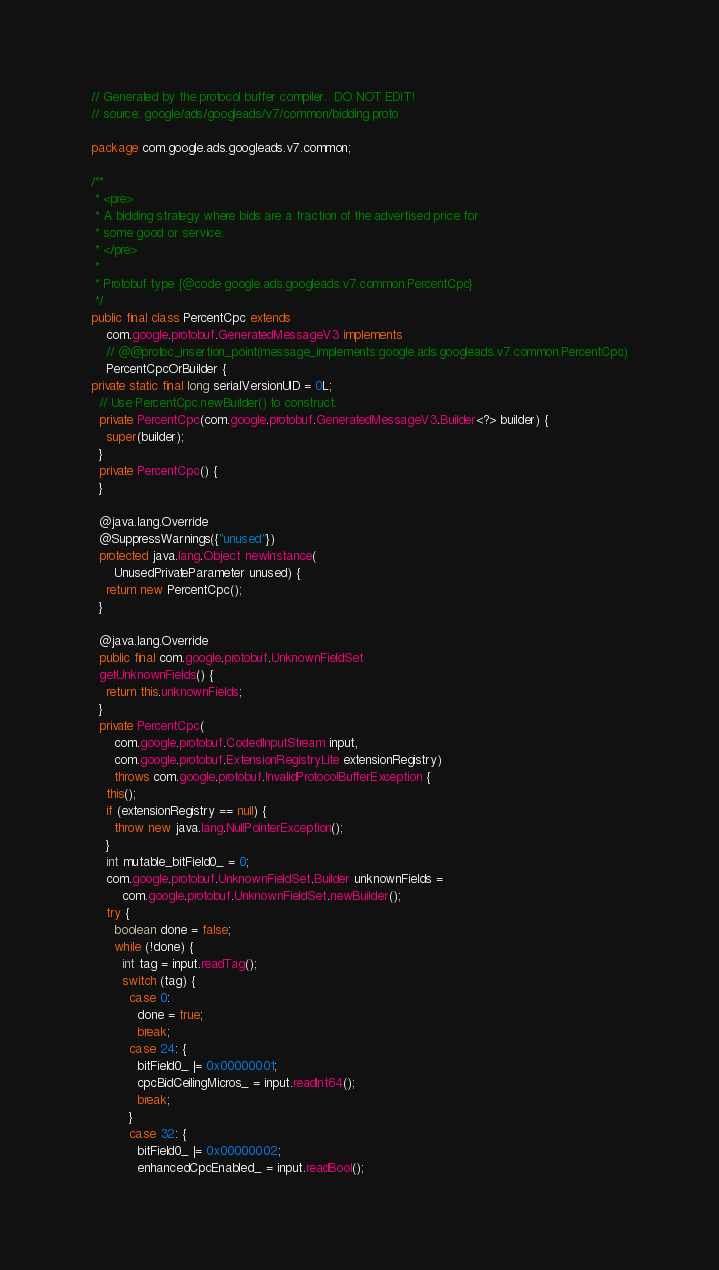Convert code to text. <code><loc_0><loc_0><loc_500><loc_500><_Java_>// Generated by the protocol buffer compiler.  DO NOT EDIT!
// source: google/ads/googleads/v7/common/bidding.proto

package com.google.ads.googleads.v7.common;

/**
 * <pre>
 * A bidding strategy where bids are a fraction of the advertised price for
 * some good or service.
 * </pre>
 *
 * Protobuf type {@code google.ads.googleads.v7.common.PercentCpc}
 */
public final class PercentCpc extends
    com.google.protobuf.GeneratedMessageV3 implements
    // @@protoc_insertion_point(message_implements:google.ads.googleads.v7.common.PercentCpc)
    PercentCpcOrBuilder {
private static final long serialVersionUID = 0L;
  // Use PercentCpc.newBuilder() to construct.
  private PercentCpc(com.google.protobuf.GeneratedMessageV3.Builder<?> builder) {
    super(builder);
  }
  private PercentCpc() {
  }

  @java.lang.Override
  @SuppressWarnings({"unused"})
  protected java.lang.Object newInstance(
      UnusedPrivateParameter unused) {
    return new PercentCpc();
  }

  @java.lang.Override
  public final com.google.protobuf.UnknownFieldSet
  getUnknownFields() {
    return this.unknownFields;
  }
  private PercentCpc(
      com.google.protobuf.CodedInputStream input,
      com.google.protobuf.ExtensionRegistryLite extensionRegistry)
      throws com.google.protobuf.InvalidProtocolBufferException {
    this();
    if (extensionRegistry == null) {
      throw new java.lang.NullPointerException();
    }
    int mutable_bitField0_ = 0;
    com.google.protobuf.UnknownFieldSet.Builder unknownFields =
        com.google.protobuf.UnknownFieldSet.newBuilder();
    try {
      boolean done = false;
      while (!done) {
        int tag = input.readTag();
        switch (tag) {
          case 0:
            done = true;
            break;
          case 24: {
            bitField0_ |= 0x00000001;
            cpcBidCeilingMicros_ = input.readInt64();
            break;
          }
          case 32: {
            bitField0_ |= 0x00000002;
            enhancedCpcEnabled_ = input.readBool();</code> 